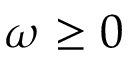Convert formula to latex. <formula><loc_0><loc_0><loc_500><loc_500>\omega \geq 0</formula> 